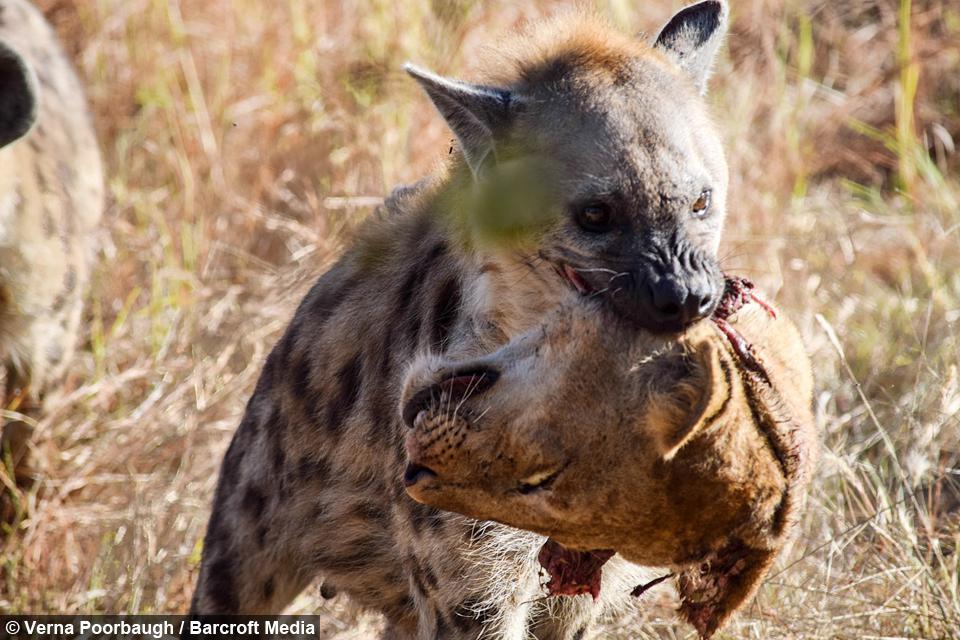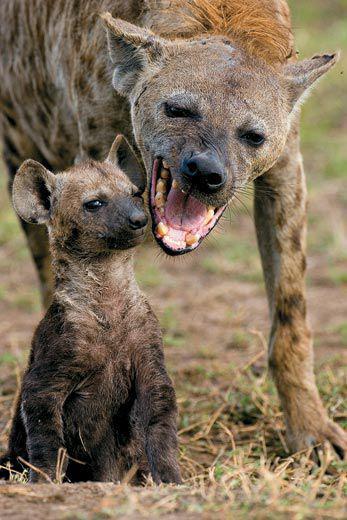The first image is the image on the left, the second image is the image on the right. Analyze the images presented: Is the assertion "Right image shows exactly one hyena, which is baring its fangs." valid? Answer yes or no. No. 